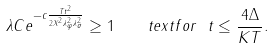<formula> <loc_0><loc_0><loc_500><loc_500>\lambda C e ^ { - c \frac { T t ^ { 2 } } { 2 \| X \| ^ { 2 } \lambda _ { \varphi } ^ { 2 } \lambda _ { \sigma } ^ { 2 } } } \geq 1 \quad t e x t { f o r } \ t \leq \frac { 4 \Delta } { K T } .</formula> 